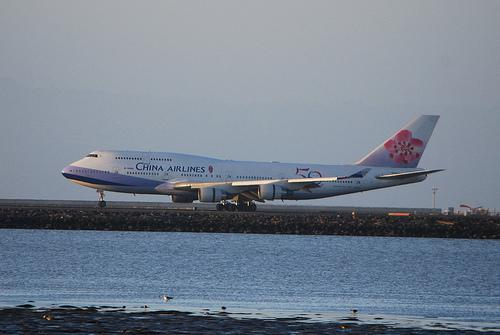Question: what airline is this?
Choices:
A. American Airlines.
B. Southwest Airlines.
C. Delta Airlines.
D. China airlines.
Answer with the letter. Answer: D Question: what is the weather like?
Choices:
A. Clear.
B. Cloudy.
C. Grey.
D. Sunny.
Answer with the letter. Answer: B Question: what design is on the tail of the plane?
Choices:
A. Panda.
B. Flower.
C. Check mark.
D. Airplane.
Answer with the letter. Answer: B Question: where is the plane?
Choices:
A. In the air.
B. In the hangar.
C. On the runway.
D. At the gate.
Answer with the letter. Answer: C Question: who is on the water?
Choices:
A. Everyone.
B. The team.
C. No one.
D. The kids.
Answer with the letter. Answer: C 